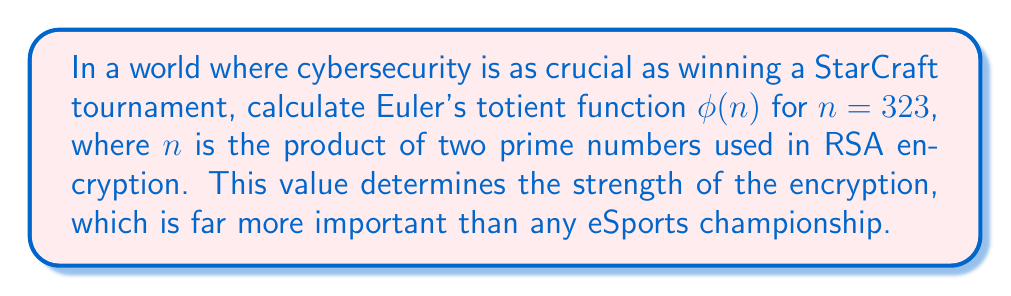Give your solution to this math problem. To calculate Euler's totient function $\phi(n)$ for $n = 323$, we follow these steps:

1) First, we need to find the prime factors of 323. 
   $323 = 17 \times 19$

2) For a number $n$ that is the product of two distinct primes $p$ and $q$, Euler's totient function is given by:
   $$\phi(n) = (p-1)(q-1)$$

3) In this case:
   $p = 17$ and $q = 19$

4) Now we can calculate:
   $$\phi(323) = (17-1)(19-1)$$
   $$\phi(323) = 16 \times 18$$
   $$\phi(323) = 288$$

5) Therefore, the value of Euler's totient function for $n = 323$ is 288.

This value is crucial in RSA encryption as it's used to generate the public and private keys, ensuring secure communication - a skill far more valuable in the long run than competitive gaming.
Answer: $288$ 